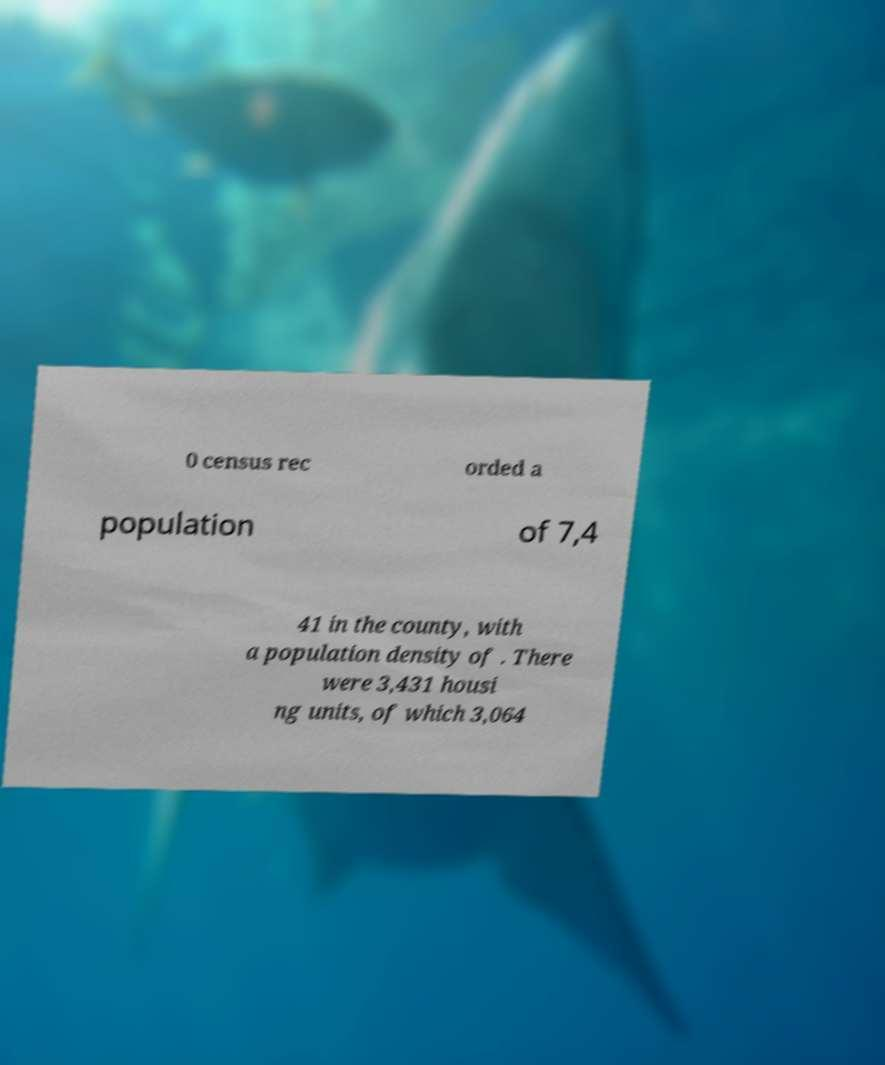Please read and relay the text visible in this image. What does it say? 0 census rec orded a population of 7,4 41 in the county, with a population density of . There were 3,431 housi ng units, of which 3,064 